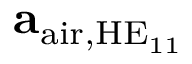Convert formula to latex. <formula><loc_0><loc_0><loc_500><loc_500>a _ { a i r , H E _ { 1 1 } }</formula> 